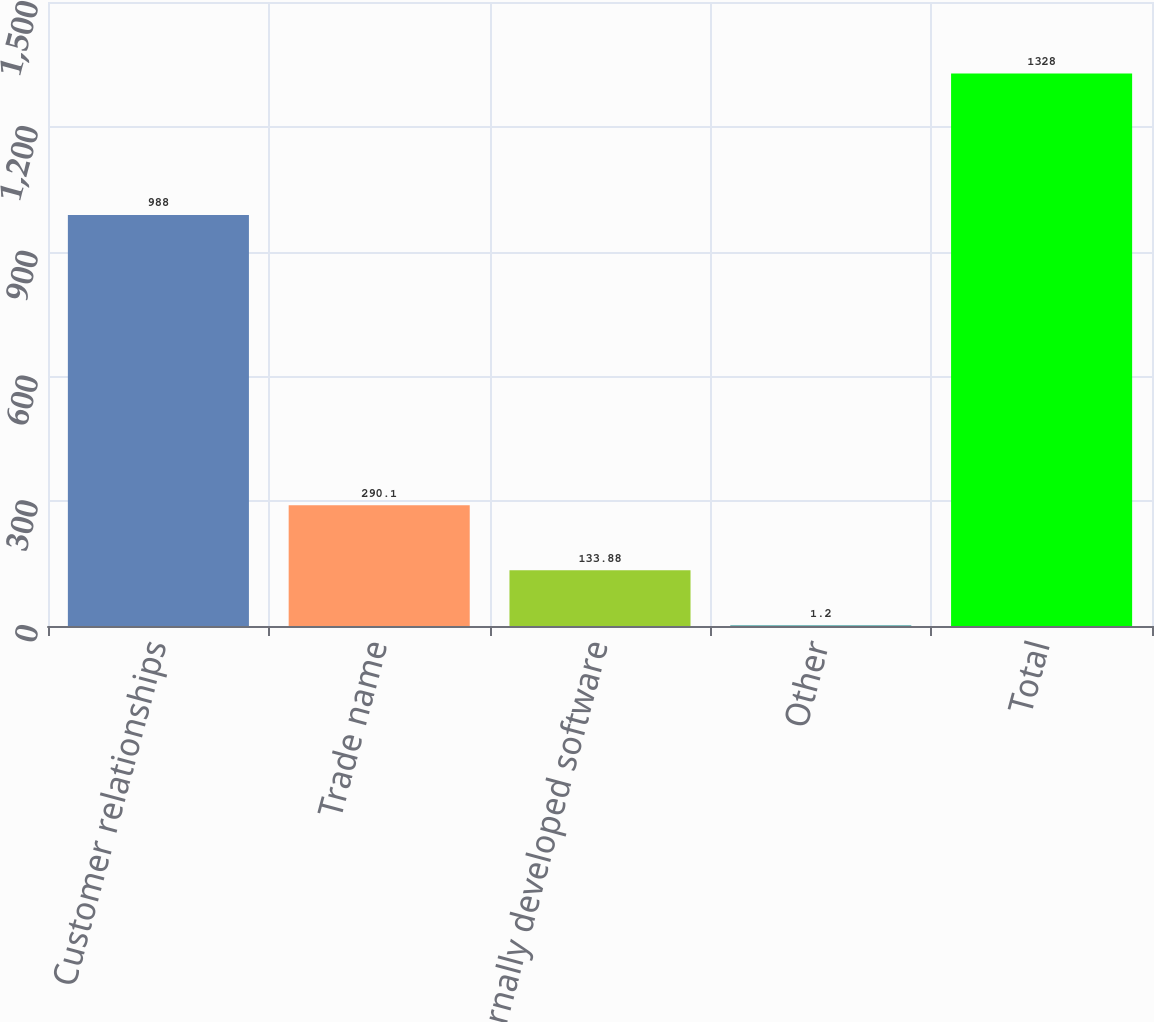Convert chart. <chart><loc_0><loc_0><loc_500><loc_500><bar_chart><fcel>Customer relationships<fcel>Trade name<fcel>Internally developed software<fcel>Other<fcel>Total<nl><fcel>988<fcel>290.1<fcel>133.88<fcel>1.2<fcel>1328<nl></chart> 